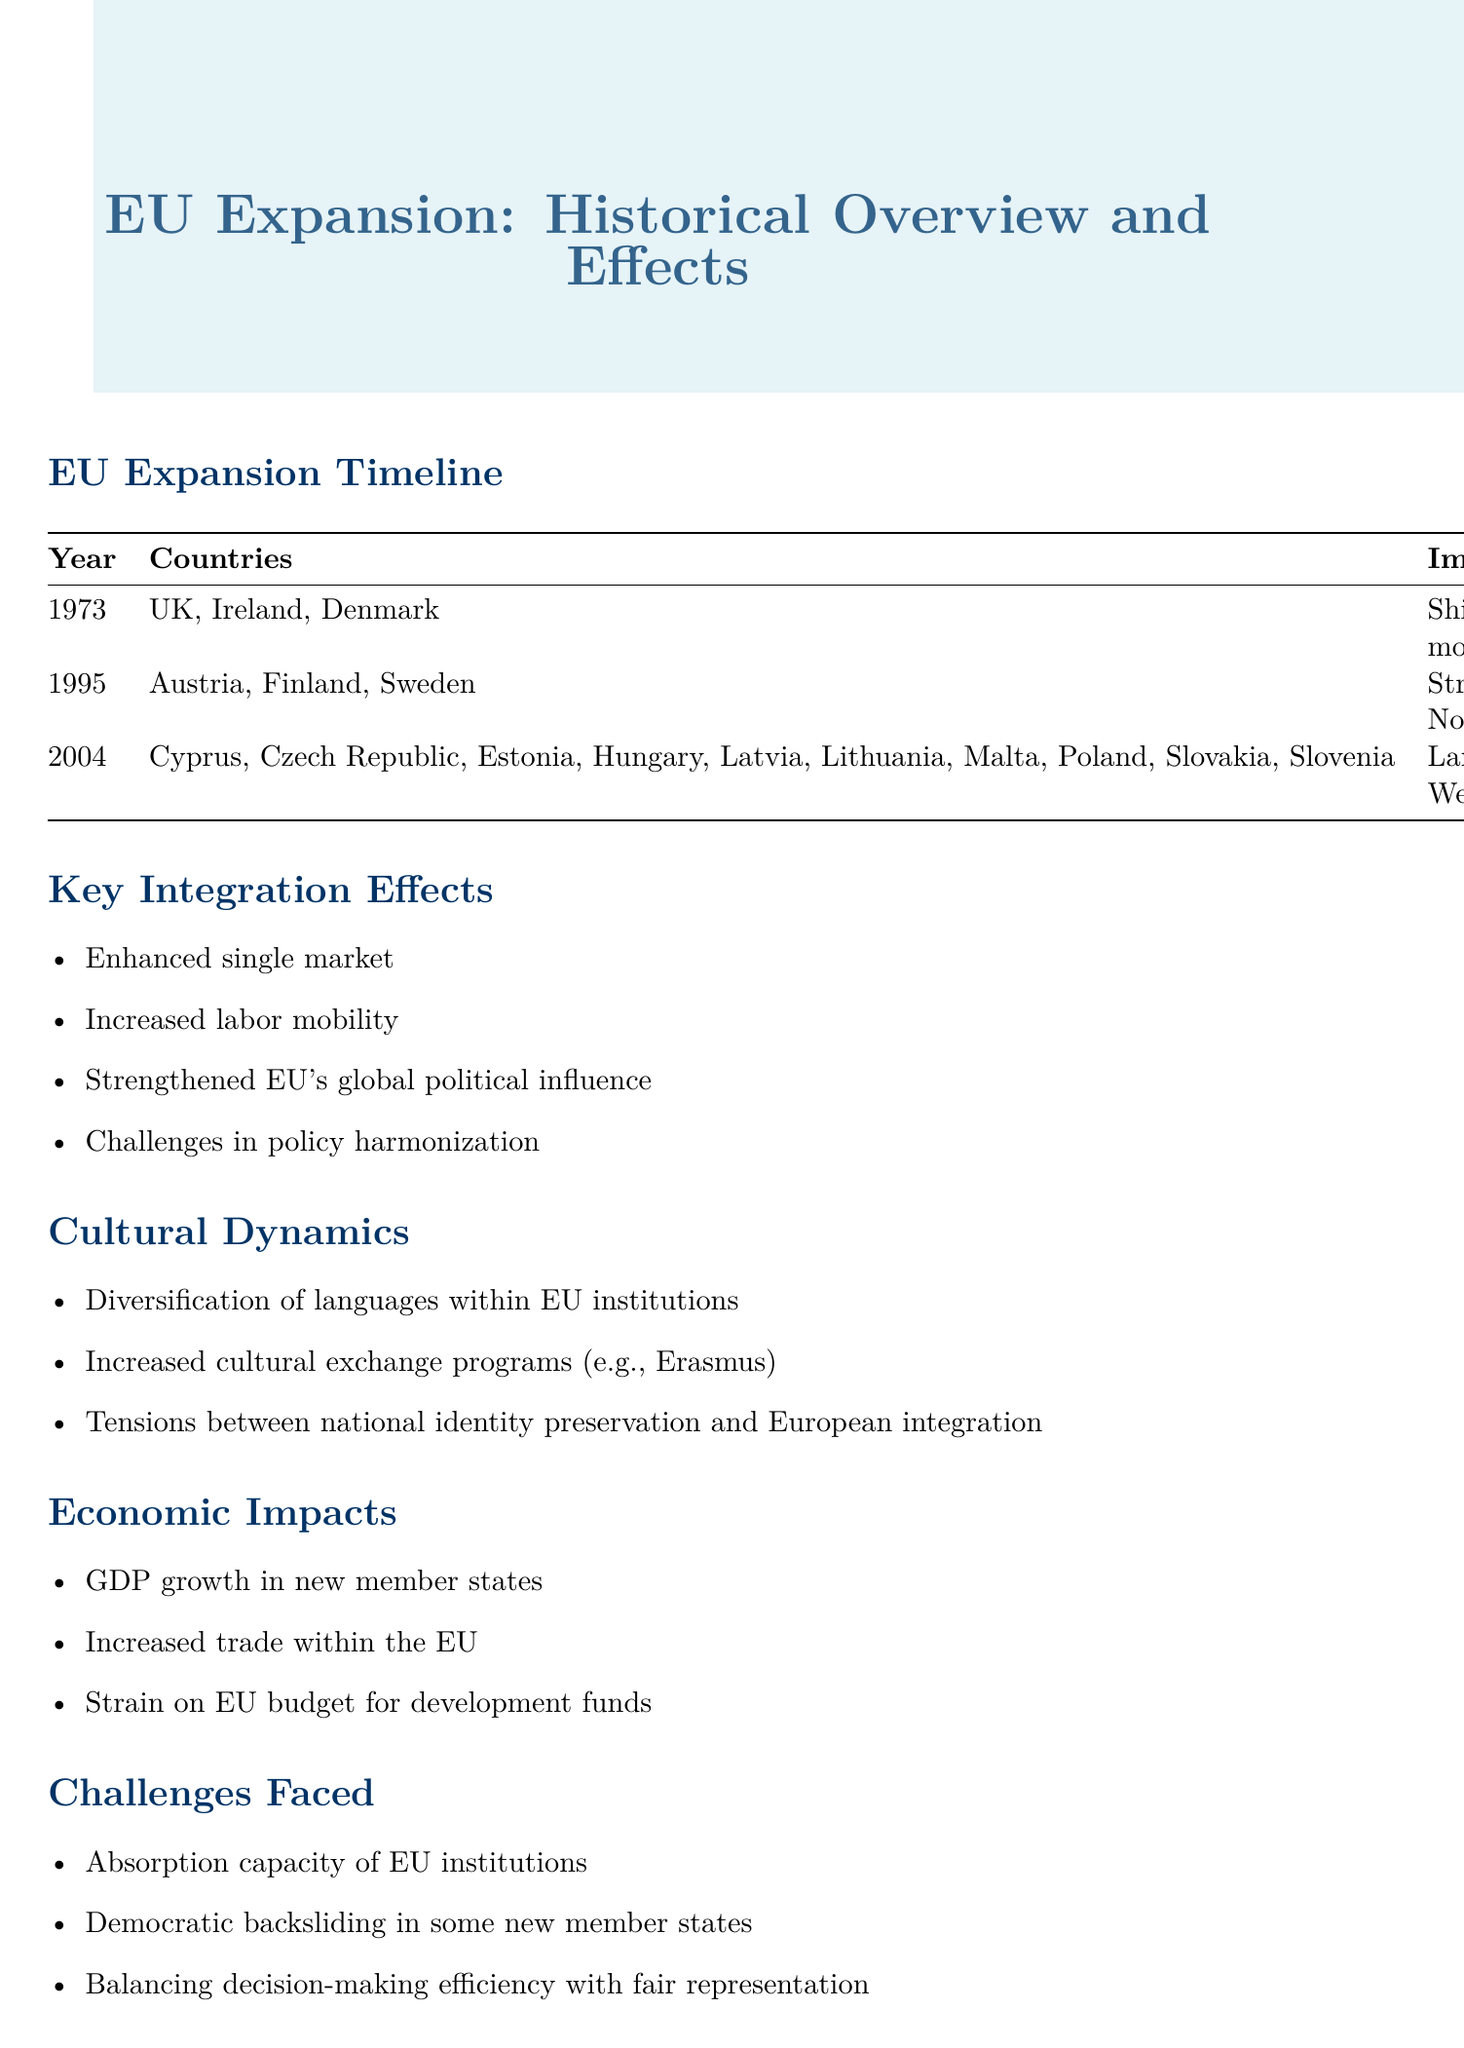What year did the UK, Ireland, and Denmark join the EU? The document states that the UK, Ireland, and Denmark joined the EU in 1973.
Answer: 1973 Which countries joined the EU in 1995? The document lists Austria, Finland, and Sweden as the countries that joined the EU in 1995.
Answer: Austria, Finland, Sweden What was the impact of the 2004 expansion? According to the document, the impact of the 2004 expansion was that it bridged the East-West divide.
Answer: Bridged East-West divide What is one of the key integration effects mentioned in the document? The document lists several effects, one of which is enhanced single market.
Answer: Enhanced single market What tension is highlighted within cultural dynamics? The document mentions tensions between national identity preservation and European integration.
Answer: National identity preservation and European integration Which region is mentioned for potential future integration? The document refers to the Western Balkans as a potential area for future integration.
Answer: Western Balkans What challenge is associated with EU institutions? The document describes the absorption capacity of EU institutions as a challenge faced.
Answer: Absorption capacity What is one future consideration related to Turkey? The document notes Turkey's long-standing candidacy as a future consideration.
Answer: Turkey's long-standing candidacy 